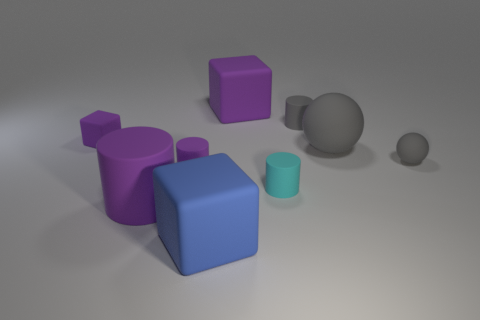There is a small cube; how many small purple objects are to the right of it?
Your response must be concise. 1. Do the small ball and the large rubber sphere have the same color?
Keep it short and to the point. Yes. What number of big objects are the same color as the small matte cube?
Offer a very short reply. 2. Is the number of large cyan matte spheres greater than the number of big blue rubber blocks?
Provide a succinct answer. No. How big is the rubber object that is on the left side of the big blue rubber object and behind the small gray sphere?
Provide a succinct answer. Small. Is the material of the big purple thing that is left of the large purple cube the same as the cube to the right of the big blue block?
Ensure brevity in your answer.  Yes. What shape is the gray object that is the same size as the gray rubber cylinder?
Make the answer very short. Sphere. Is the number of tiny gray objects less than the number of large purple metal cylinders?
Your response must be concise. No. Is there a tiny gray sphere left of the cube that is in front of the small block?
Offer a very short reply. No. Is there a small gray thing on the left side of the large rubber block in front of the large purple thing that is behind the big purple cylinder?
Keep it short and to the point. No. 